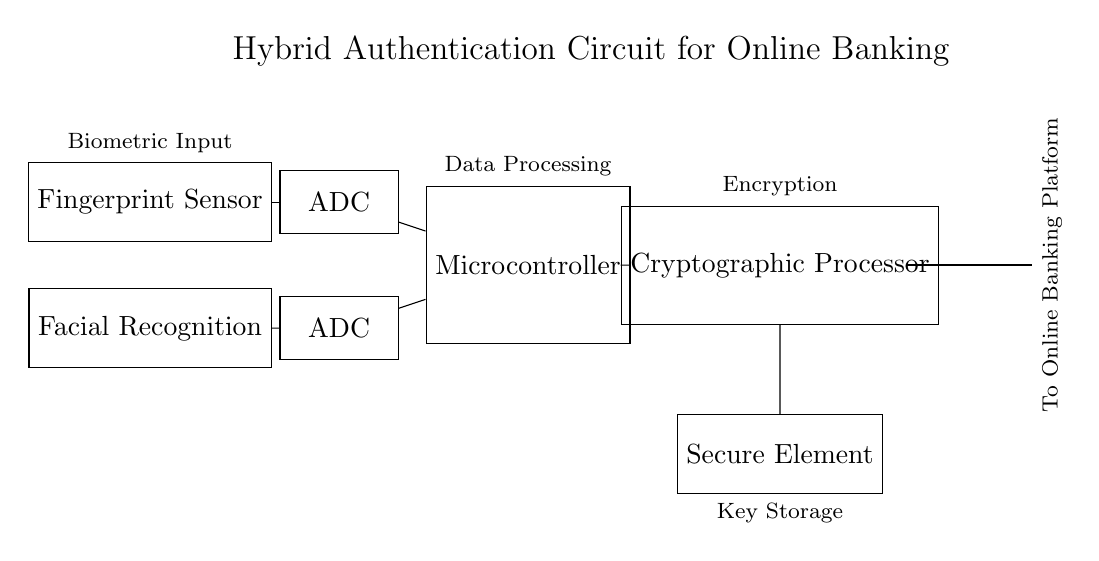What are the two types of biometric sensors used? The circuit diagram shows a Fingerprint Sensor and a Facial Recognition sensor, indicated by the labeled rectangles at the top left.
Answer: Fingerprint Sensor and Facial Recognition What component processes the output from the biometric sensors? The two biometric sensors are connected to Analog-to-Digital Converters, which convert the analog signals from the sensors into digital signals for further processing.
Answer: Analog-to-Digital Converter What does the microcontroller do? The microcontroller is responsible for processing the digital data received from the ADCs. This is indicated by its position in the circuit and the label "Data Processing" above it.
Answer: Data processing How many ADCs are present in the circuit? The circuit diagram clearly shows two separate ADC components, each connected to a different biometric sensor.
Answer: Two What is the purpose of the cryptographic processor? The cryptographic processor is responsible for encryption, as stated in the label above it. It receives processed data from the microcontroller to secure it before sending it to the Secure Element.
Answer: Encryption What is connected to the Secure Element? The Secure Element directly receives output from the Cryptographic Processor, indicating it holds sensitive keys and information that need protection, as shown in the connections within the circuit.
Answer: Cryptographic Processor What data flow direction is indicated from the circuit to the online banking platform? The circuit shows a thick line labeled "To Online Banking Platform," indicating the direction of data flow from the Secure Element to the platform, which is critical for understanding how user information is transmitted securely.
Answer: To Online Banking Platform 